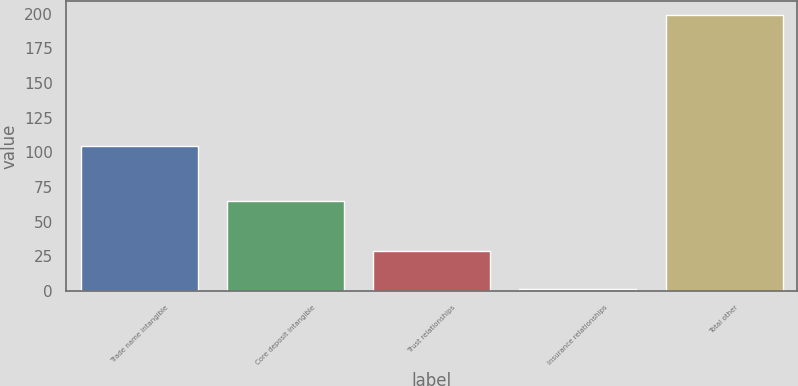Convert chart. <chart><loc_0><loc_0><loc_500><loc_500><bar_chart><fcel>Trade name intangible<fcel>Core deposit intangible<fcel>Trust relationships<fcel>Insurance relationships<fcel>Total other<nl><fcel>104.2<fcel>64.6<fcel>28.5<fcel>1.7<fcel>199<nl></chart> 